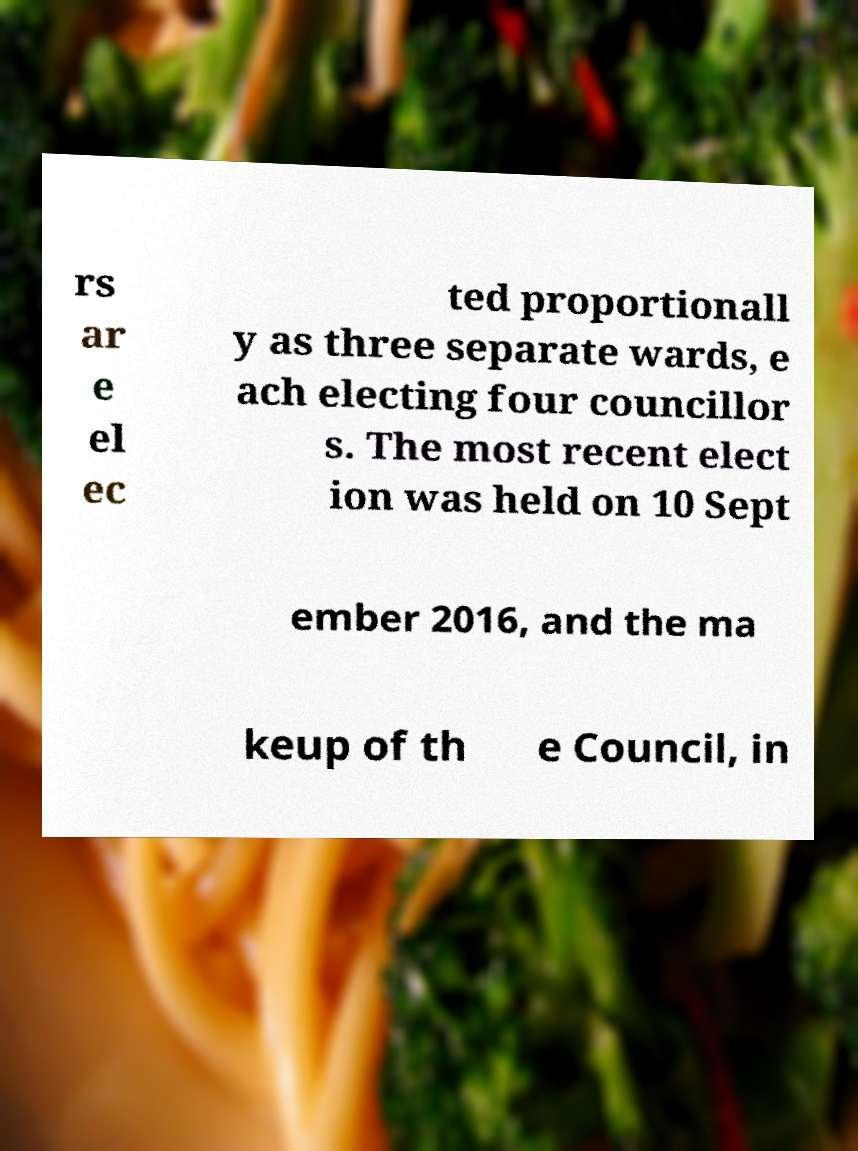Can you read and provide the text displayed in the image?This photo seems to have some interesting text. Can you extract and type it out for me? rs ar e el ec ted proportionall y as three separate wards, e ach electing four councillor s. The most recent elect ion was held on 10 Sept ember 2016, and the ma keup of th e Council, in 